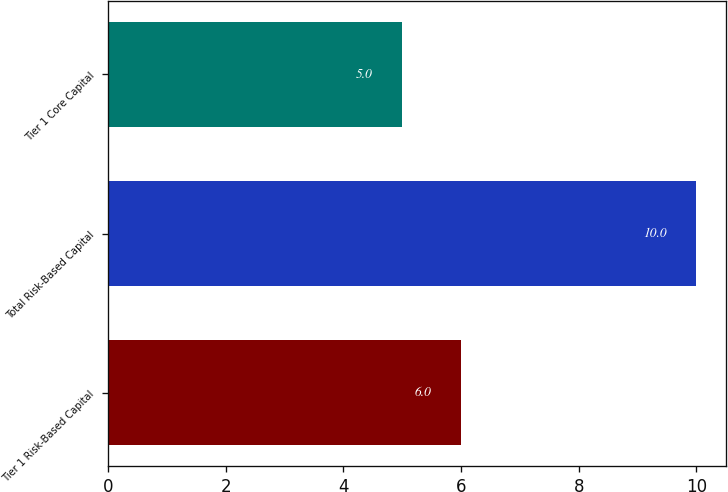<chart> <loc_0><loc_0><loc_500><loc_500><bar_chart><fcel>Tier 1 Risk-Based Capital<fcel>Total Risk-Based Capital<fcel>Tier 1 Core Capital<nl><fcel>6<fcel>10<fcel>5<nl></chart> 